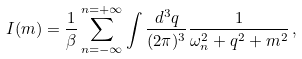<formula> <loc_0><loc_0><loc_500><loc_500>I ( m ) = \frac { 1 } { \beta } \sum _ { n = - \infty } ^ { n = + \infty } \int \frac { d ^ { 3 } q } { ( 2 \pi ) ^ { 3 } } \frac { 1 } { \omega _ { n } ^ { 2 } + q ^ { 2 } + m ^ { 2 } } \, ,</formula> 